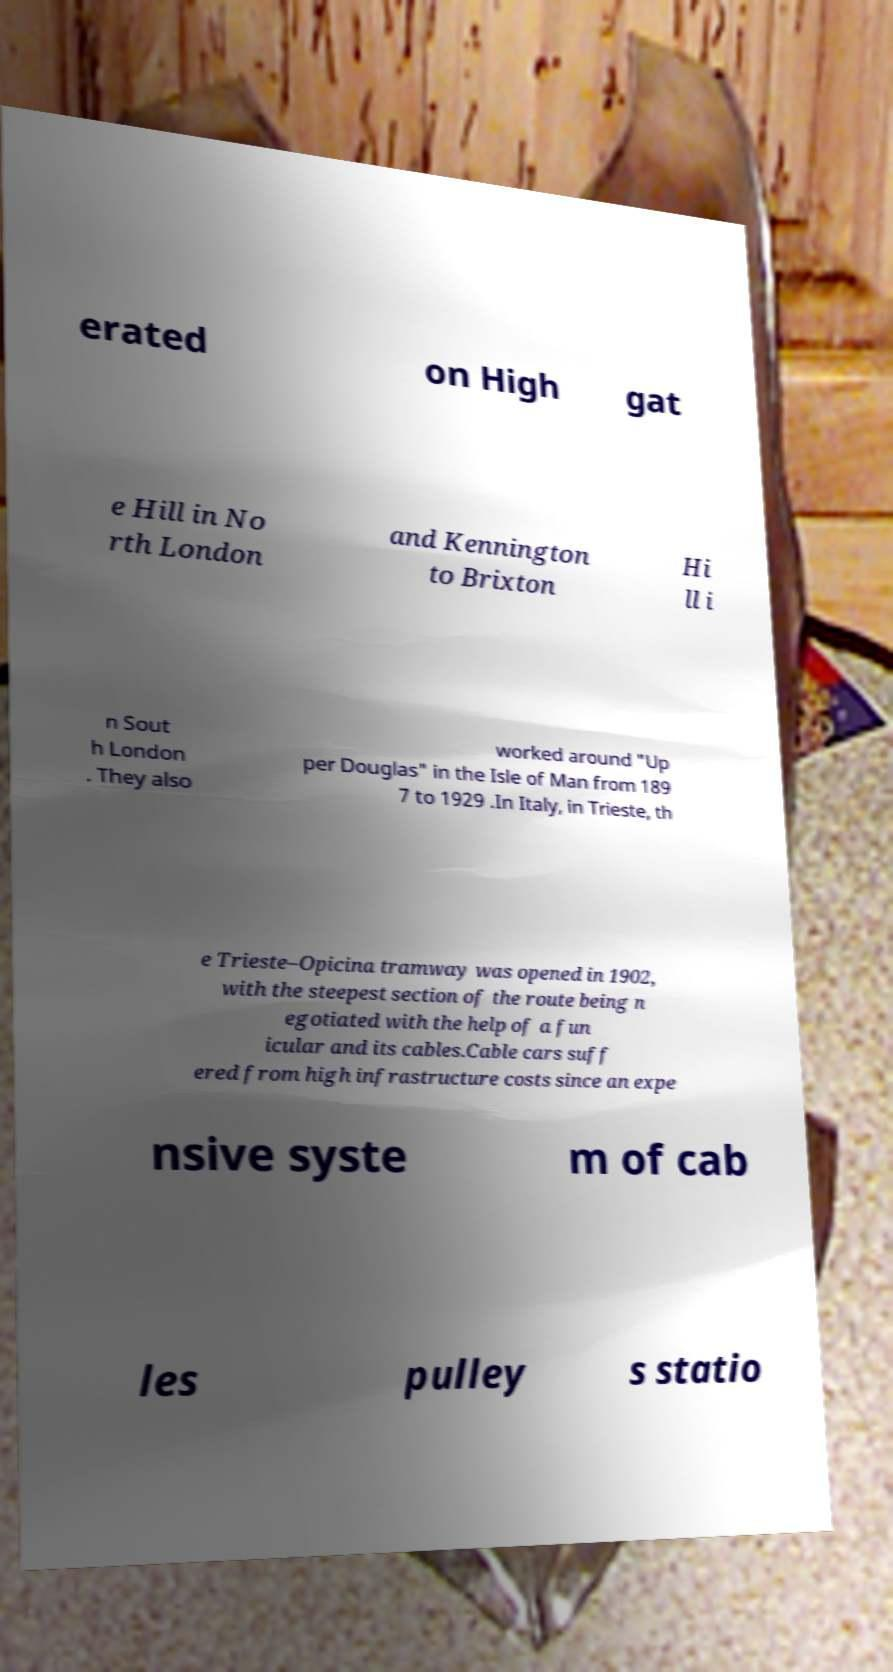I need the written content from this picture converted into text. Can you do that? erated on High gat e Hill in No rth London and Kennington to Brixton Hi ll i n Sout h London . They also worked around "Up per Douglas" in the Isle of Man from 189 7 to 1929 .In Italy, in Trieste, th e Trieste–Opicina tramway was opened in 1902, with the steepest section of the route being n egotiated with the help of a fun icular and its cables.Cable cars suff ered from high infrastructure costs since an expe nsive syste m of cab les pulley s statio 